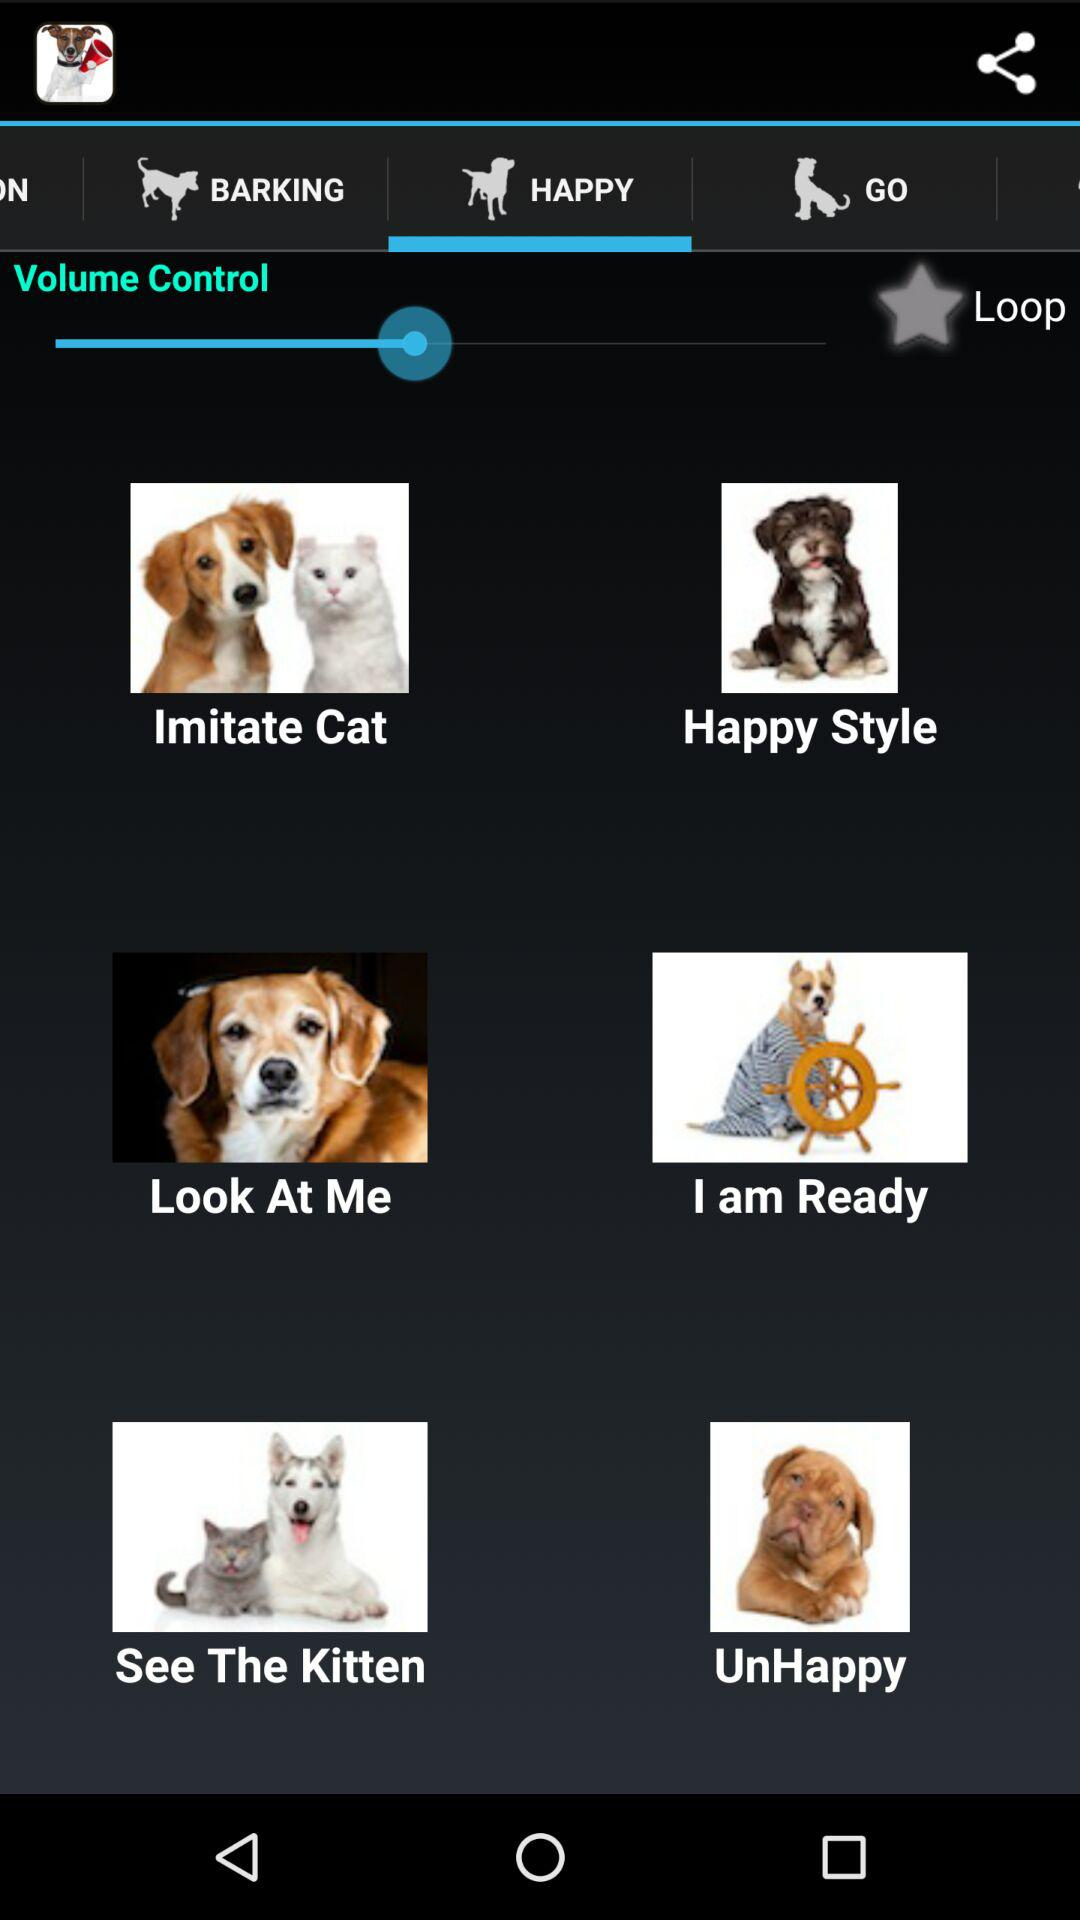Which tab is selected? The selected tab is "HAPPY". 